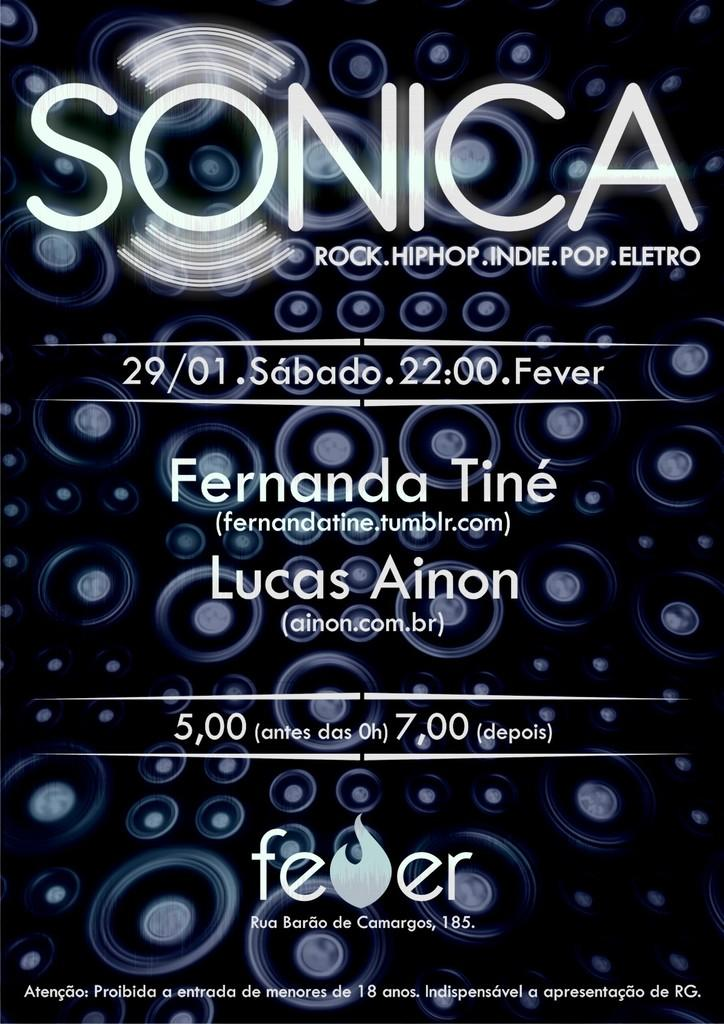<image>
Render a clear and concise summary of the photo. an advertisement that has the name Lucas on it 